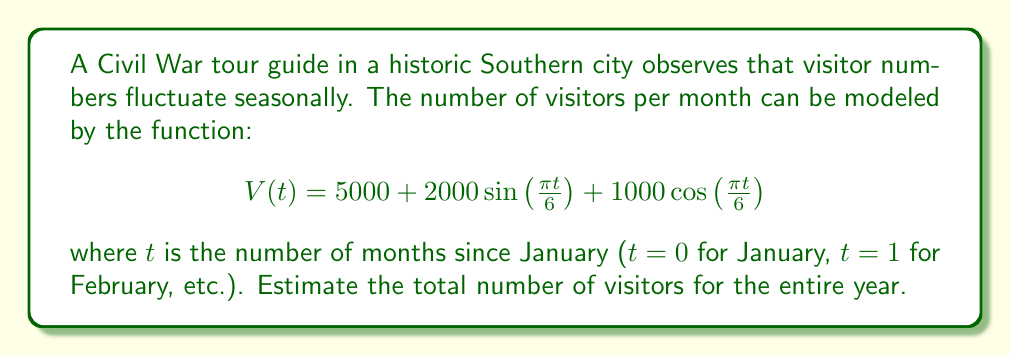Solve this math problem. To estimate the total number of visitors for the year, we need to integrate the function $V(t)$ over one full year (12 months). Let's break this down step-by-step:

1) The integral we need to evaluate is:

   $$\int_0^{12} V(t) dt = \int_0^{12} \left(5000 + 2000\sin\left(\frac{\pi t}{6}\right) + 1000\cos\left(\frac{\pi t}{6}\right)\right) dt$$

2) Let's integrate each term separately:

   a) For the constant term: 
      $$\int_0^{12} 5000 dt = 5000t \bigg|_0^{12} = 60000$$

   b) For the sine term:
      $$\int_0^{12} 2000\sin\left(\frac{\pi t}{6}\right) dt = -\frac{12000}{\pi} \cos\left(\frac{\pi t}{6}\right) \bigg|_0^{12} = 0$$

   c) For the cosine term:
      $$\int_0^{12} 1000\cos\left(\frac{\pi t}{6}\right) dt = \frac{6000}{\pi} \sin\left(\frac{\pi t}{6}\right) \bigg|_0^{12} = 0$$

3) The sine and cosine terms integrate to zero over a full period, which makes sense as they represent fluctuations above and below the average.

4) Therefore, the total number of visitors for the year is simply the average monthly visitors (5000) multiplied by 12 months.
Answer: The estimated total number of visitors for the entire year is 60,000. 